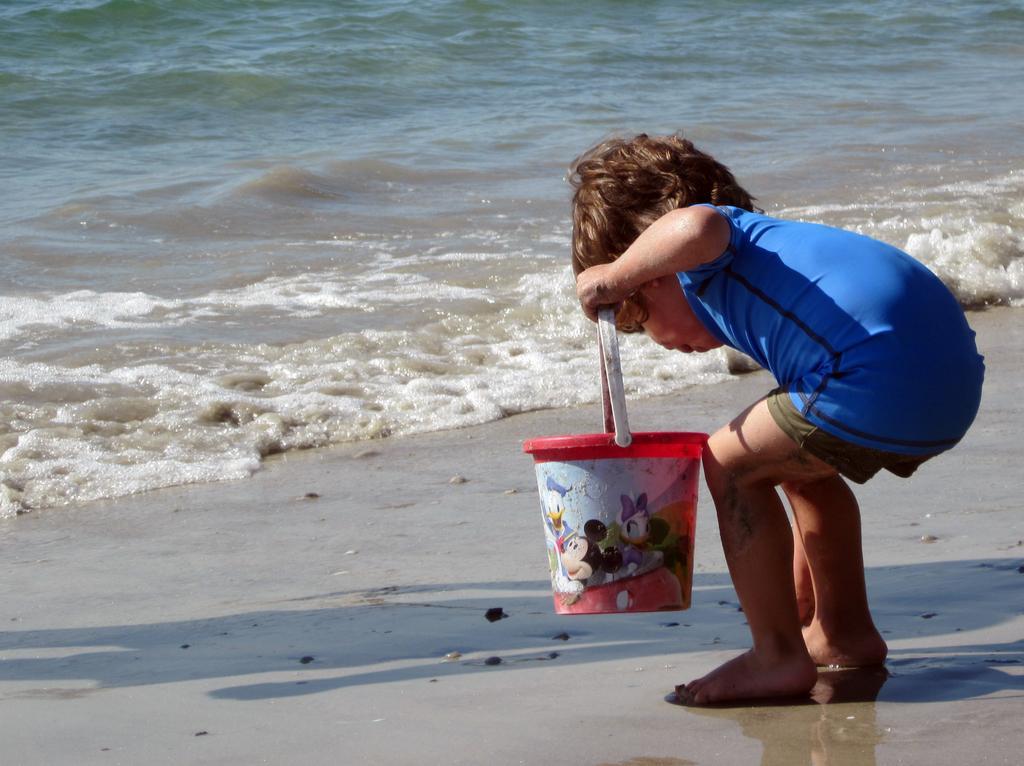Describe this image in one or two sentences. In this image we can see a child standing on the seashore holding a bucket. We can also see some stones and the water. 